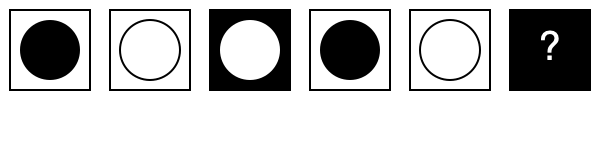What shape should replace the question mark to complete the pattern? To solve this pattern recognition question, let's break it down step-by-step:

1. Observe the sequence of shapes:
   - Square with black circle
   - Square with white circle
   - Black square with white circle
   - Square with black circle
   - Square with white circle
   - Black square with ?

2. Notice that the pattern repeats every three shapes:
   - First: Square with black circle
   - Second: Square with white circle
   - Third: Black square with white circle

3. The last shape we see is a black square, which corresponds to the third shape in the pattern.

4. Following the pattern, the next shape should be the first in the sequence: a square with a black circle.

5. However, since the square is already black, we only need to add a white circle to complete the pattern.

This type of pattern recognition question can help students with learning disabilities practice visual processing and logical thinking skills in a structured, predictable format.
Answer: White circle 